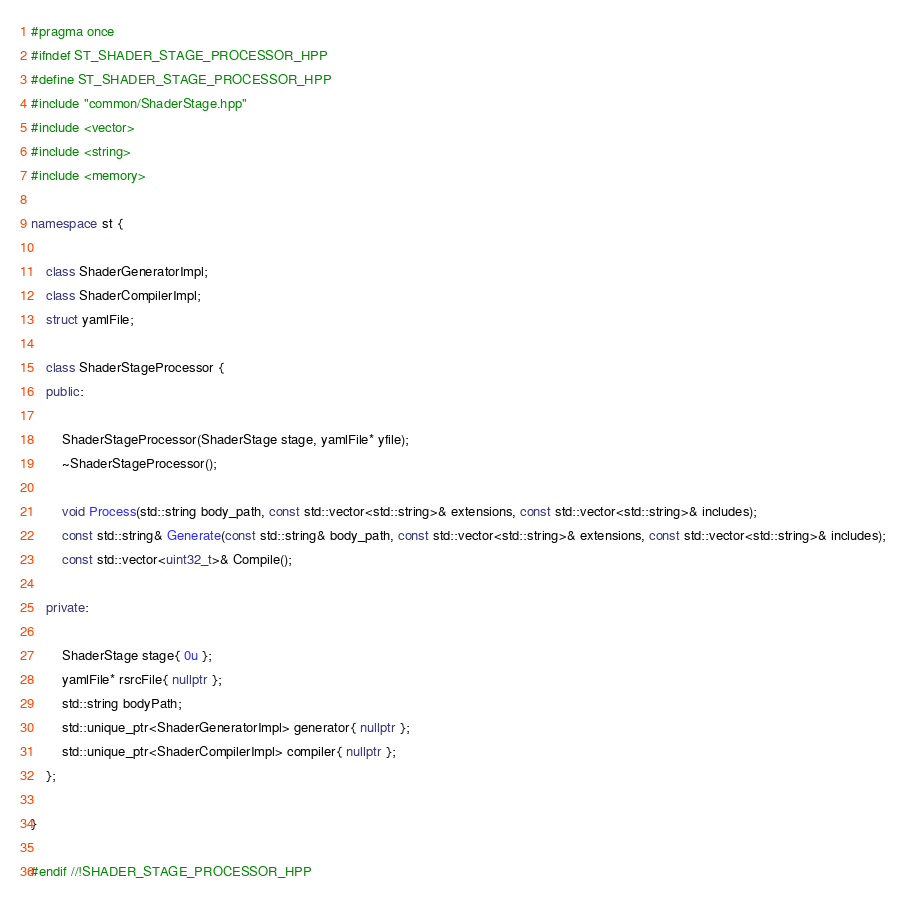<code> <loc_0><loc_0><loc_500><loc_500><_C++_>#pragma once
#ifndef ST_SHADER_STAGE_PROCESSOR_HPP
#define ST_SHADER_STAGE_PROCESSOR_HPP
#include "common/ShaderStage.hpp"
#include <vector>
#include <string>
#include <memory>

namespace st {

    class ShaderGeneratorImpl;
    class ShaderCompilerImpl;
    struct yamlFile;

    class ShaderStageProcessor {
    public:

        ShaderStageProcessor(ShaderStage stage, yamlFile* yfile);
        ~ShaderStageProcessor();

        void Process(std::string body_path, const std::vector<std::string>& extensions, const std::vector<std::string>& includes);
        const std::string& Generate(const std::string& body_path, const std::vector<std::string>& extensions, const std::vector<std::string>& includes);
        const std::vector<uint32_t>& Compile();

    private:

        ShaderStage stage{ 0u };
        yamlFile* rsrcFile{ nullptr };
        std::string bodyPath;
        std::unique_ptr<ShaderGeneratorImpl> generator{ nullptr };
        std::unique_ptr<ShaderCompilerImpl> compiler{ nullptr };
    };

}

#endif //!SHADER_STAGE_PROCESSOR_HPP
</code> 